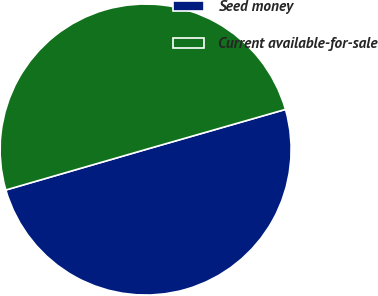<chart> <loc_0><loc_0><loc_500><loc_500><pie_chart><fcel>Seed money<fcel>Current available-for-sale<nl><fcel>49.96%<fcel>50.04%<nl></chart> 